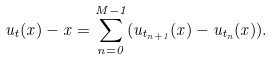Convert formula to latex. <formula><loc_0><loc_0><loc_500><loc_500>u _ { t } ( x ) - x = \sum _ { n = 0 } ^ { M - 1 } ( u _ { t _ { n + 1 } } ( x ) - u _ { t _ { n } } ( x ) ) .</formula> 